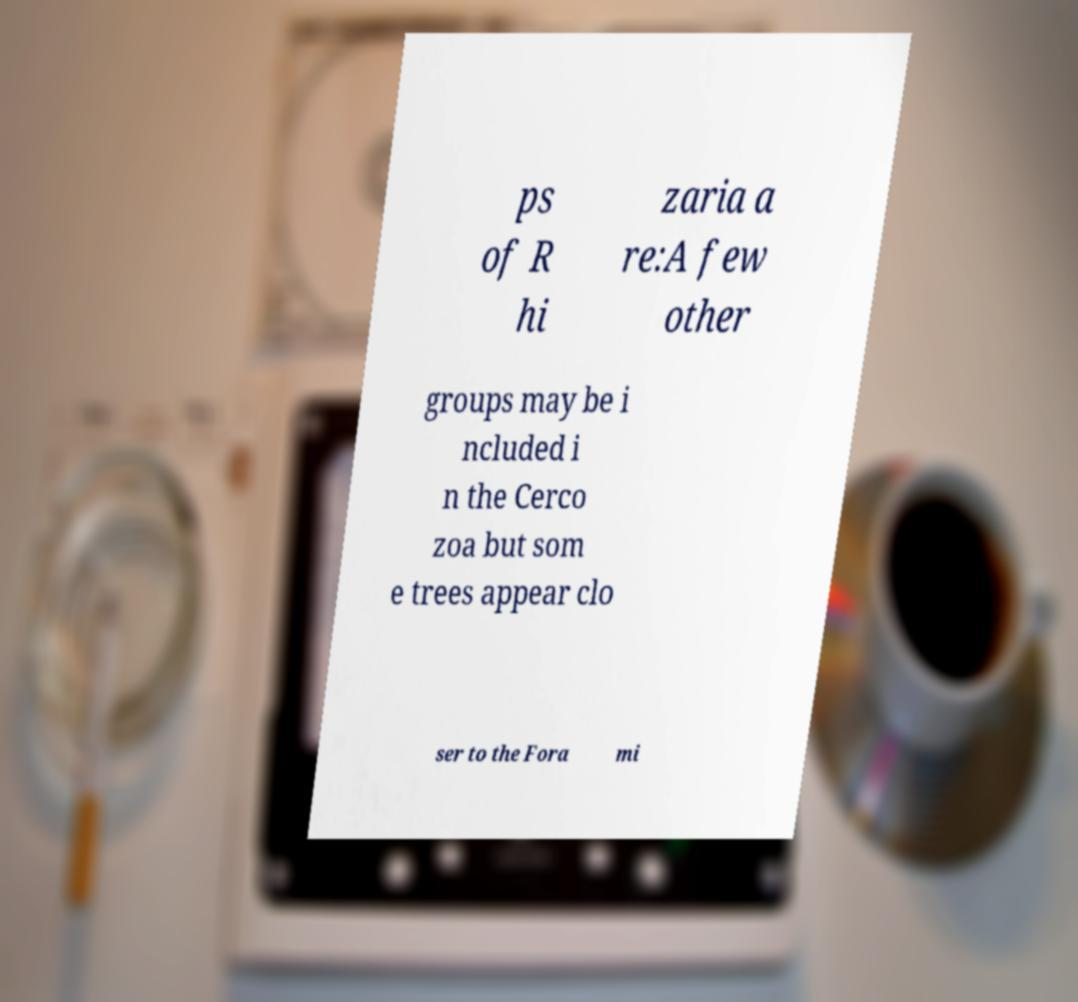For documentation purposes, I need the text within this image transcribed. Could you provide that? ps of R hi zaria a re:A few other groups may be i ncluded i n the Cerco zoa but som e trees appear clo ser to the Fora mi 